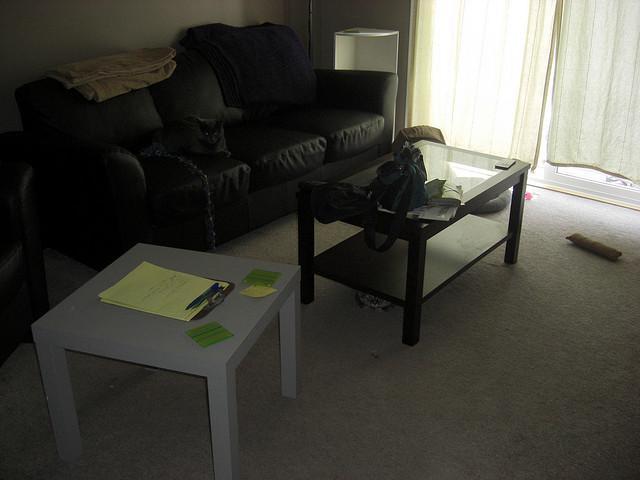What color has two post-its?
From the following set of four choices, select the accurate answer to respond to the question.
Options: Orange, green, blue, yellow. Green. 